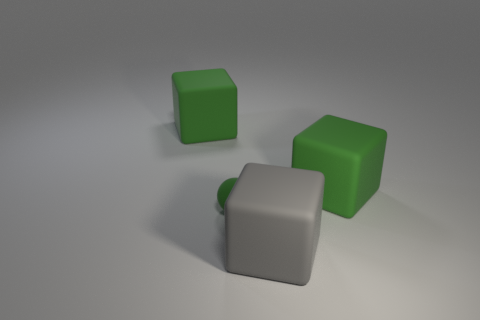There is a big gray object in front of the tiny ball; is it the same shape as the green thing right of the tiny green ball?
Keep it short and to the point. Yes. Is the number of big green matte objects left of the small rubber object less than the number of balls behind the big gray block?
Keep it short and to the point. No. How many gray blocks are the same size as the gray thing?
Provide a succinct answer. 0. Are the block on the left side of the big gray matte object and the tiny sphere made of the same material?
Make the answer very short. Yes. Are there any purple things?
Give a very brief answer. No. The gray cube that is the same material as the sphere is what size?
Offer a very short reply. Large. Are there any large objects that have the same color as the tiny sphere?
Make the answer very short. Yes. Is the color of the rubber object in front of the small matte ball the same as the large rubber object that is left of the green matte sphere?
Your response must be concise. No. Are there any other green spheres that have the same material as the small ball?
Provide a succinct answer. No. The tiny ball has what color?
Your response must be concise. Green. 